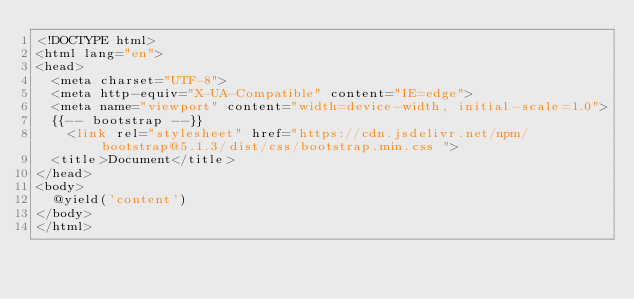<code> <loc_0><loc_0><loc_500><loc_500><_PHP_><!DOCTYPE html>
<html lang="en">
<head>
  <meta charset="UTF-8">
  <meta http-equiv="X-UA-Compatible" content="IE=edge">
  <meta name="viewport" content="width=device-width, initial-scale=1.0">
  {{-- bootstrap --}}
    <link rel="stylesheet" href="https://cdn.jsdelivr.net/npm/bootstrap@5.1.3/dist/css/bootstrap.min.css ">
  <title>Document</title>
</head>
<body>
  @yield('content')
</body>
</html></code> 